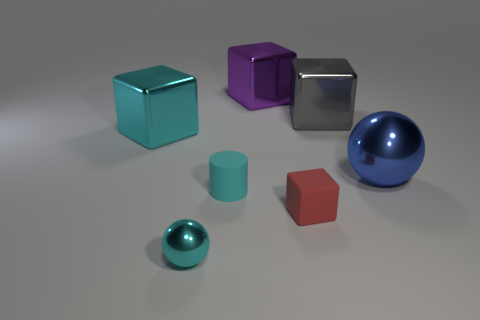Subtract all metallic blocks. How many blocks are left? 1 Add 2 small brown cubes. How many objects exist? 9 Subtract all cyan spheres. How many spheres are left? 1 Subtract 1 cyan spheres. How many objects are left? 6 Subtract all balls. How many objects are left? 5 Subtract 1 balls. How many balls are left? 1 Subtract all blue cubes. Subtract all green balls. How many cubes are left? 4 Subtract all brown cubes. How many blue balls are left? 1 Subtract all gray spheres. Subtract all big purple cubes. How many objects are left? 6 Add 4 matte objects. How many matte objects are left? 6 